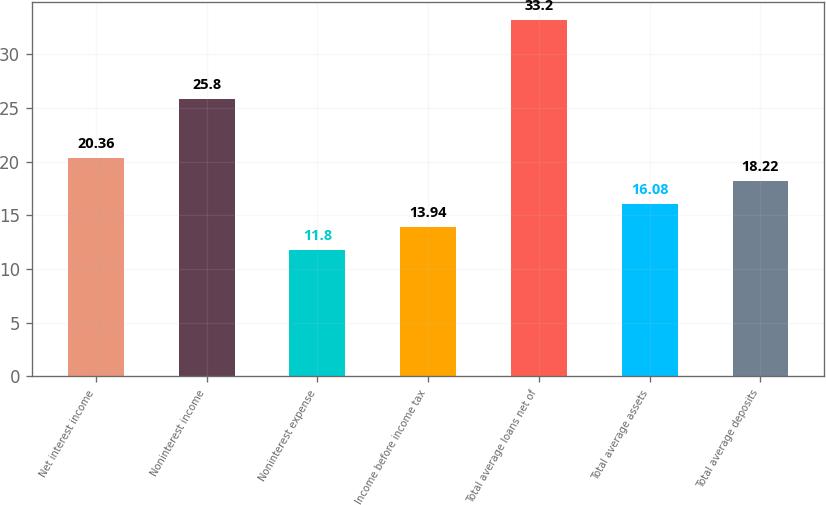Convert chart. <chart><loc_0><loc_0><loc_500><loc_500><bar_chart><fcel>Net interest income<fcel>Noninterest income<fcel>Noninterest expense<fcel>Income before income tax<fcel>Total average loans net of<fcel>Total average assets<fcel>Total average deposits<nl><fcel>20.36<fcel>25.8<fcel>11.8<fcel>13.94<fcel>33.2<fcel>16.08<fcel>18.22<nl></chart> 